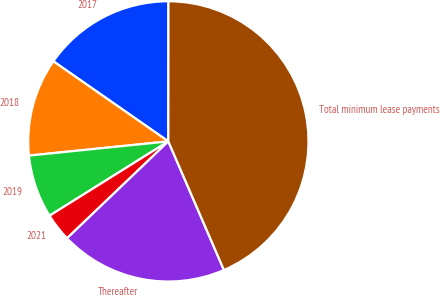Convert chart to OTSL. <chart><loc_0><loc_0><loc_500><loc_500><pie_chart><fcel>2017<fcel>2018<fcel>2019<fcel>2021<fcel>Thereafter<fcel>Total minimum lease payments<nl><fcel>15.33%<fcel>11.3%<fcel>7.28%<fcel>3.25%<fcel>19.35%<fcel>43.5%<nl></chart> 